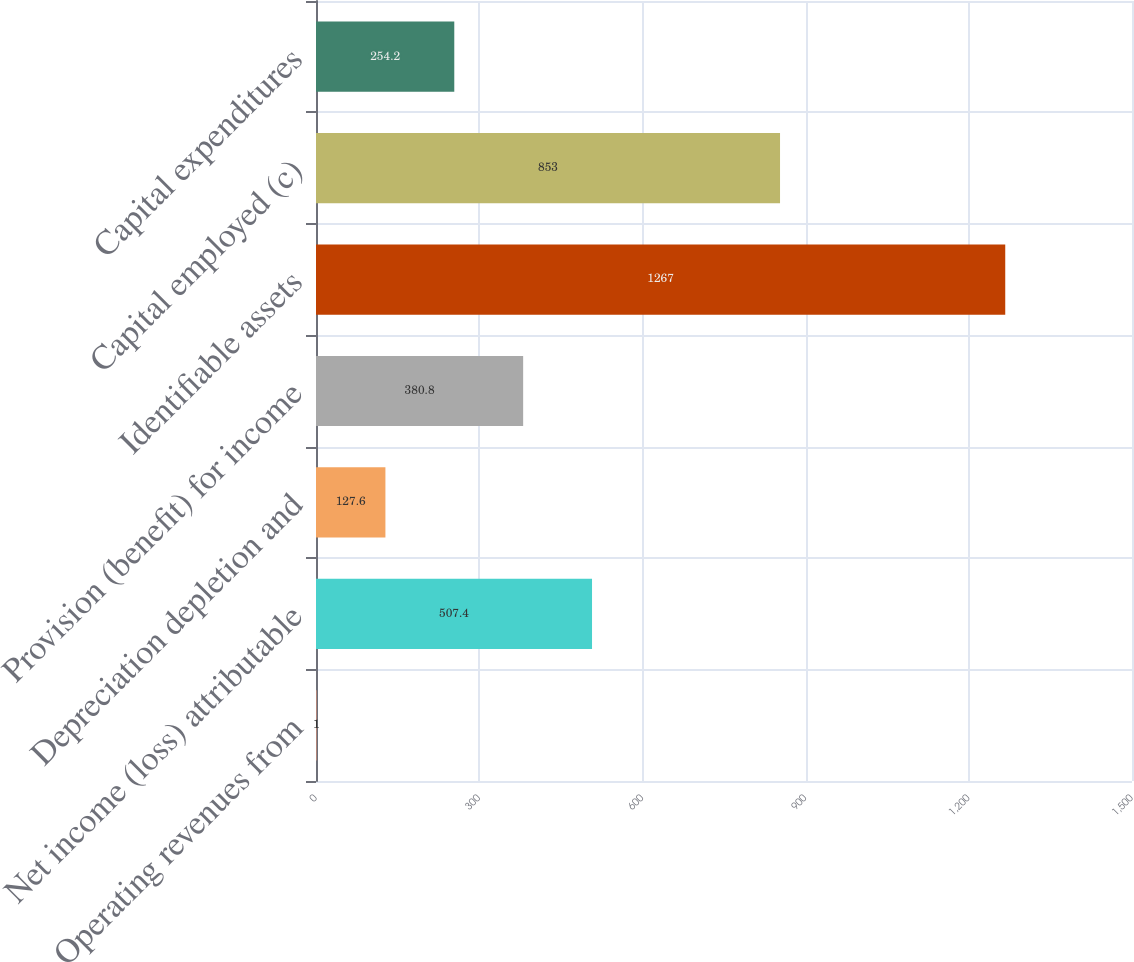Convert chart. <chart><loc_0><loc_0><loc_500><loc_500><bar_chart><fcel>Operating revenues from<fcel>Net income (loss) attributable<fcel>Depreciation depletion and<fcel>Provision (benefit) for income<fcel>Identifiable assets<fcel>Capital employed (c)<fcel>Capital expenditures<nl><fcel>1<fcel>507.4<fcel>127.6<fcel>380.8<fcel>1267<fcel>853<fcel>254.2<nl></chart> 